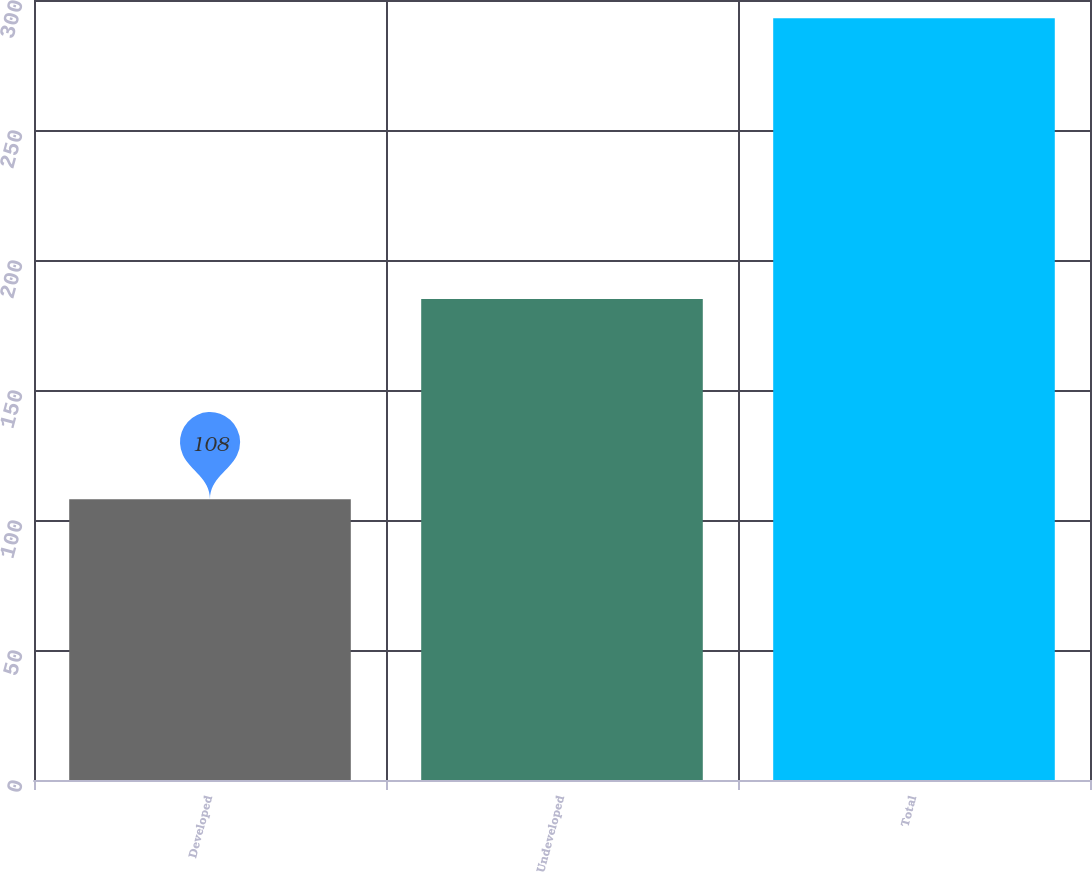<chart> <loc_0><loc_0><loc_500><loc_500><bar_chart><fcel>Developed<fcel>Undeveloped<fcel>Total<nl><fcel>108<fcel>185<fcel>293<nl></chart> 